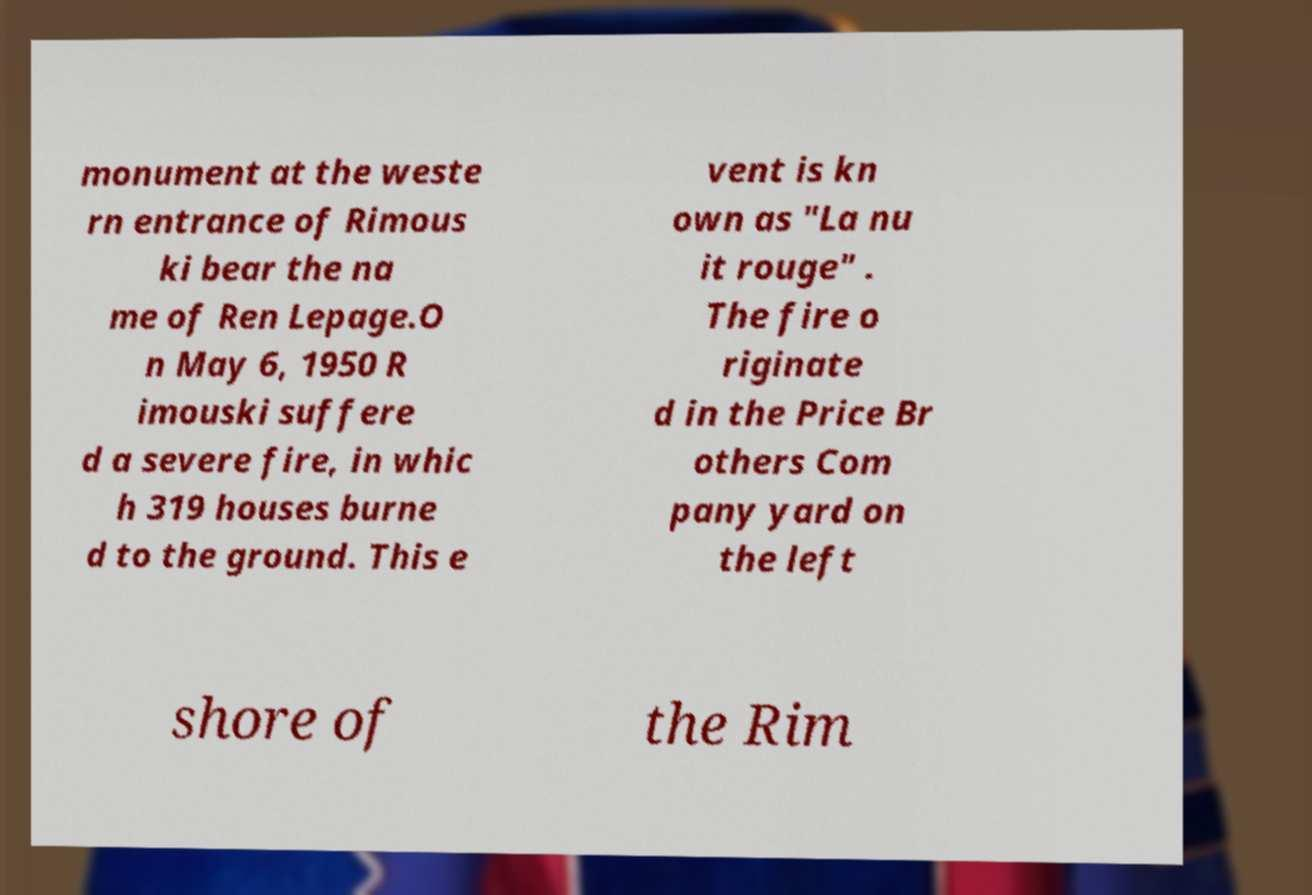Please identify and transcribe the text found in this image. monument at the weste rn entrance of Rimous ki bear the na me of Ren Lepage.O n May 6, 1950 R imouski suffere d a severe fire, in whic h 319 houses burne d to the ground. This e vent is kn own as "La nu it rouge" . The fire o riginate d in the Price Br others Com pany yard on the left shore of the Rim 